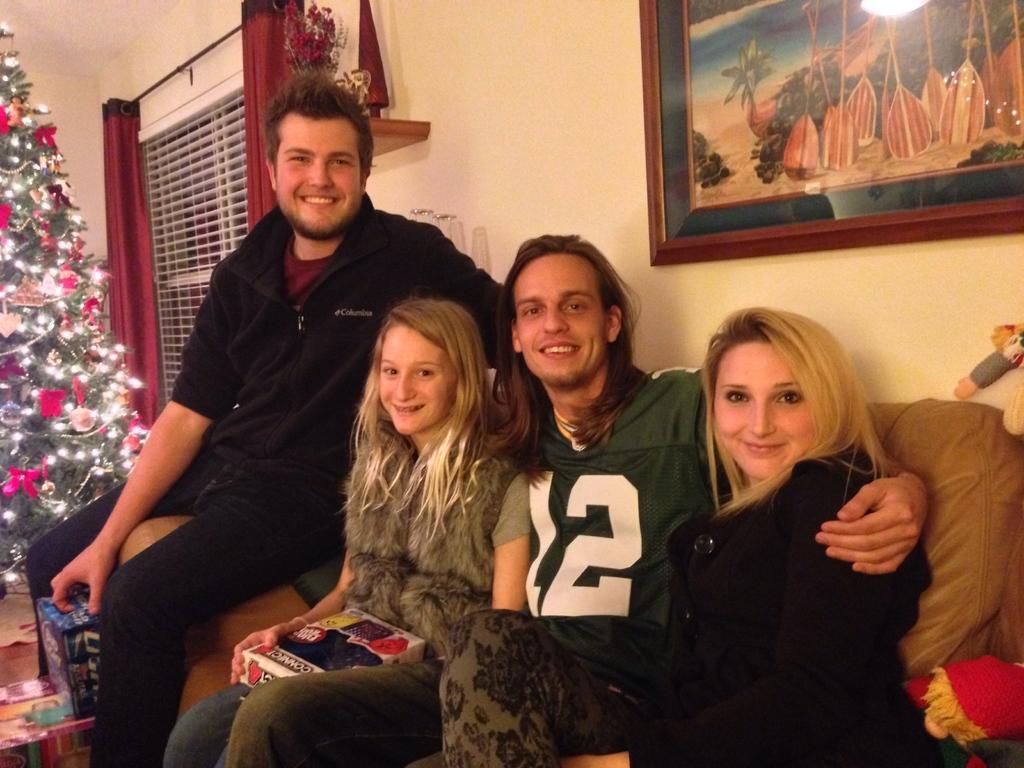Can you describe this image briefly? In this image I can see a group of people sitting on the sofa. On the left side I can see a tree. In the background, I can see a photo frame on the wall. 